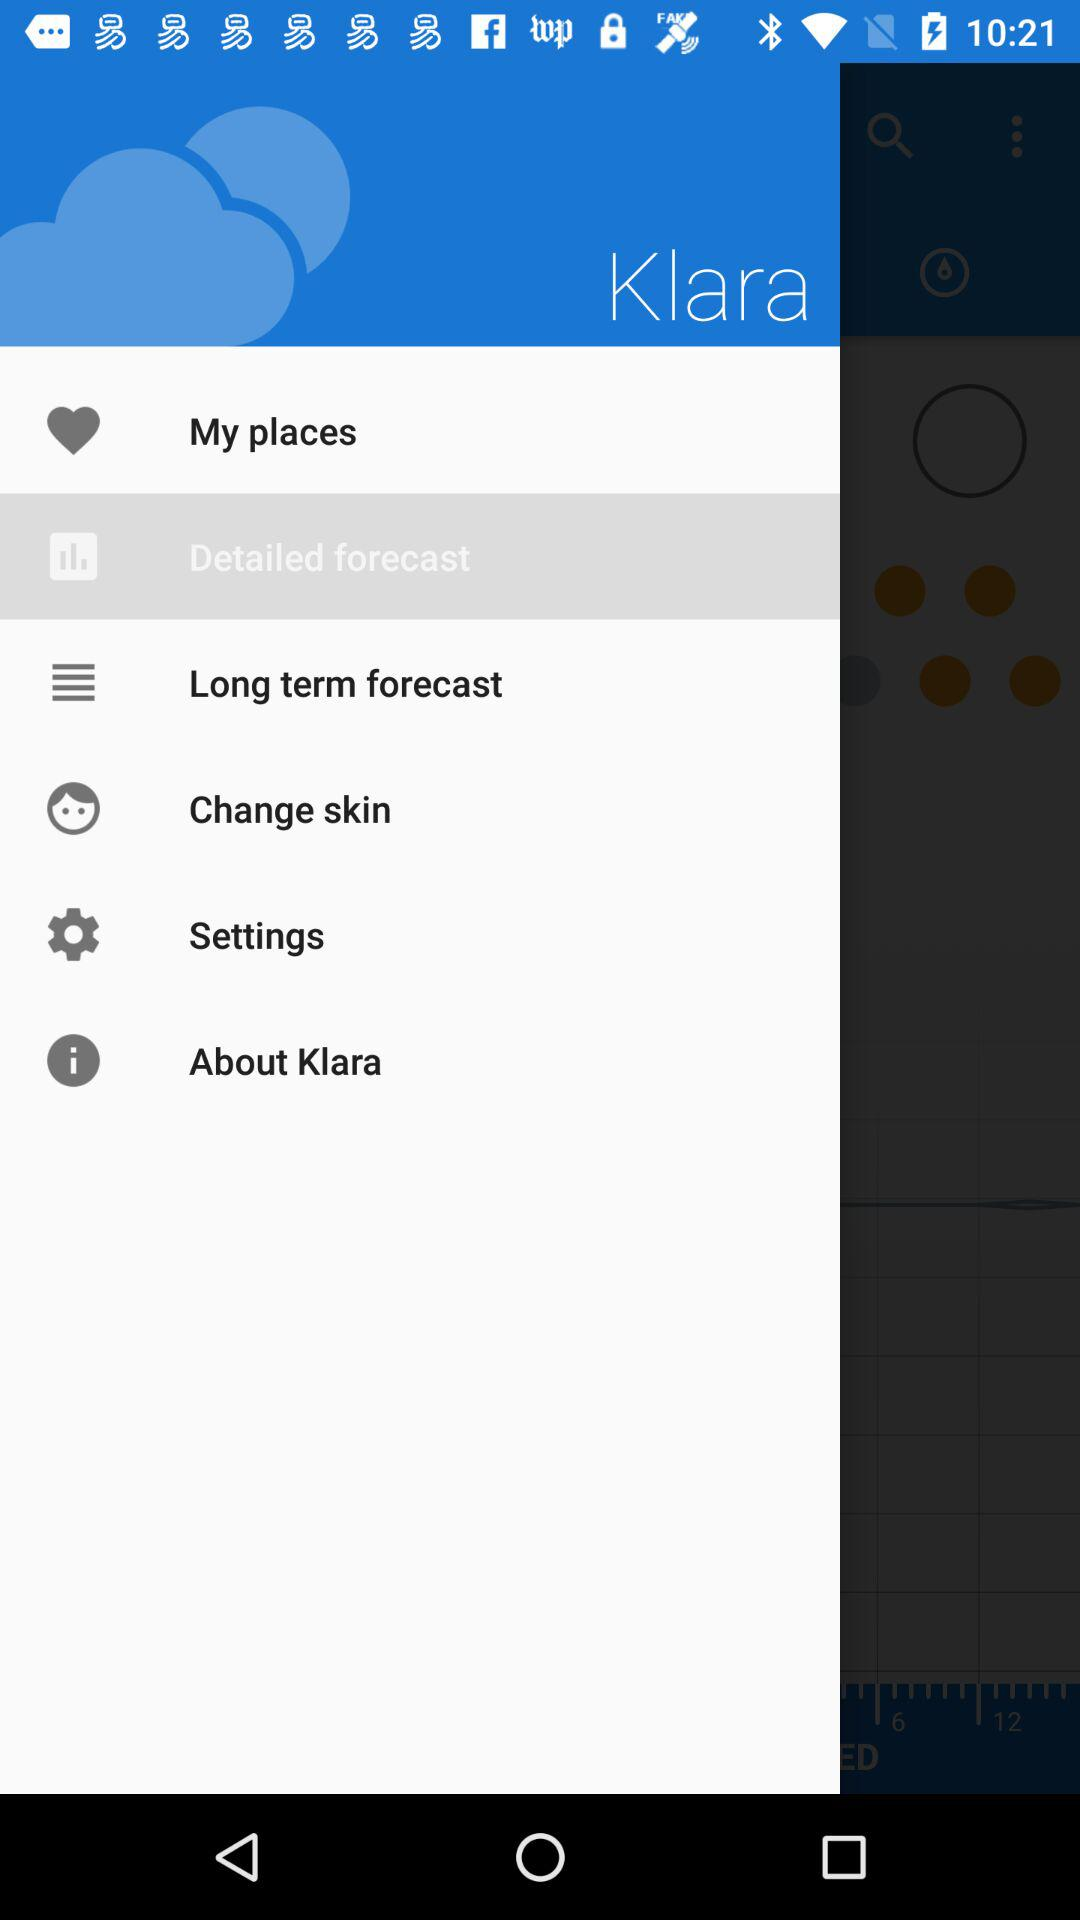What is the user's name?
When the provided information is insufficient, respond with <no answer>. <no answer> 